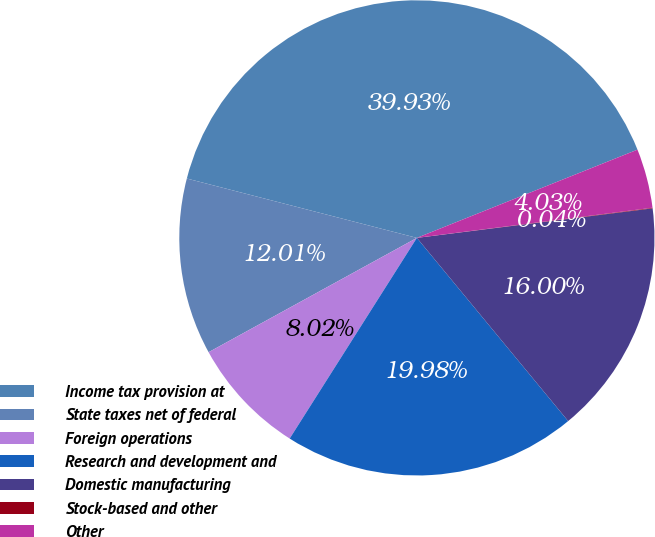Convert chart. <chart><loc_0><loc_0><loc_500><loc_500><pie_chart><fcel>Income tax provision at<fcel>State taxes net of federal<fcel>Foreign operations<fcel>Research and development and<fcel>Domestic manufacturing<fcel>Stock-based and other<fcel>Other<nl><fcel>39.93%<fcel>12.01%<fcel>8.02%<fcel>19.98%<fcel>16.0%<fcel>0.04%<fcel>4.03%<nl></chart> 